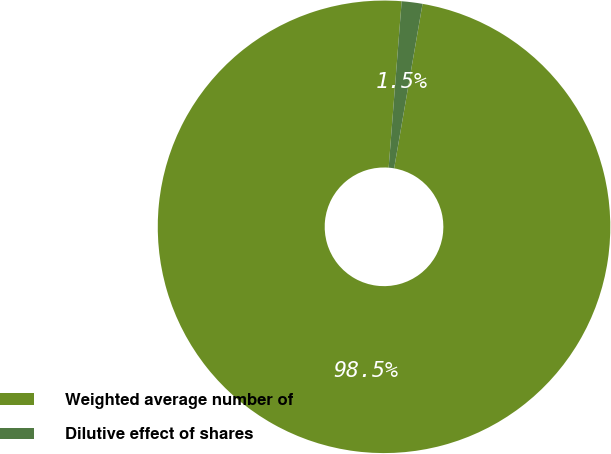Convert chart to OTSL. <chart><loc_0><loc_0><loc_500><loc_500><pie_chart><fcel>Weighted average number of<fcel>Dilutive effect of shares<nl><fcel>98.52%<fcel>1.48%<nl></chart> 